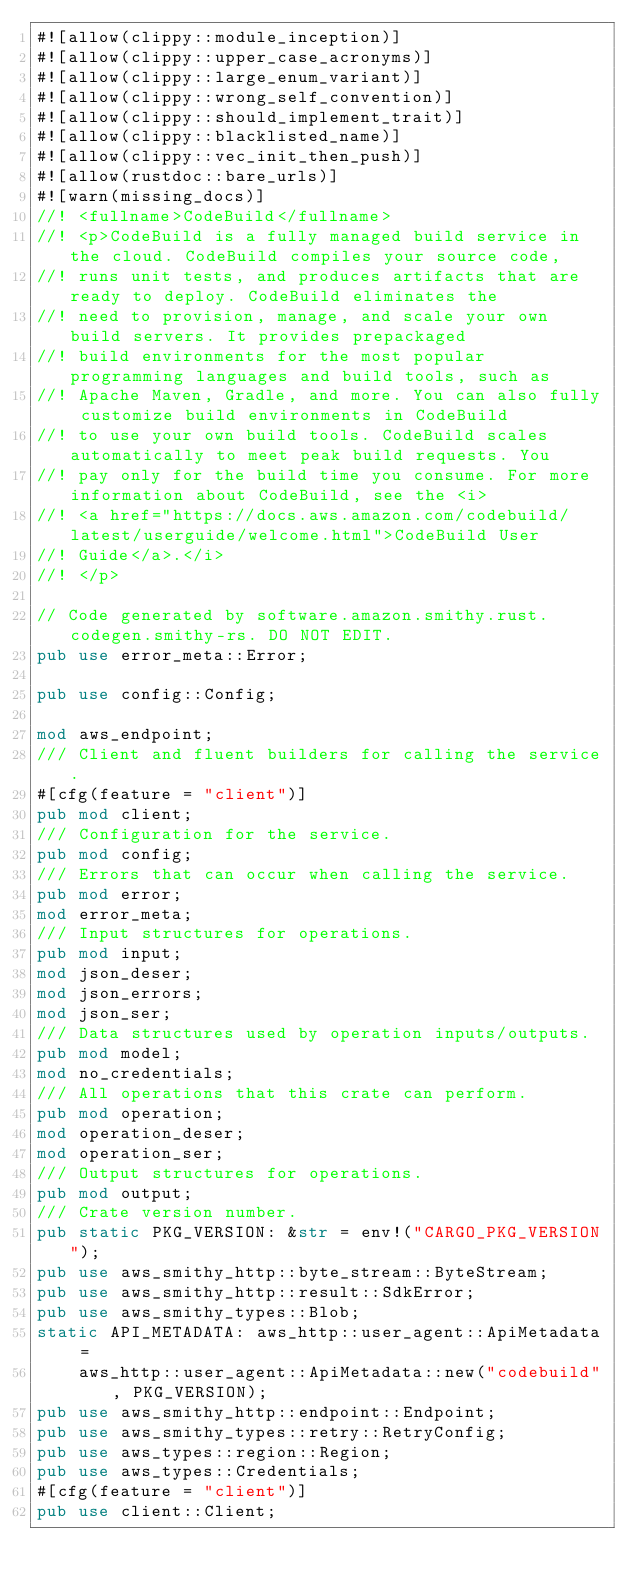Convert code to text. <code><loc_0><loc_0><loc_500><loc_500><_Rust_>#![allow(clippy::module_inception)]
#![allow(clippy::upper_case_acronyms)]
#![allow(clippy::large_enum_variant)]
#![allow(clippy::wrong_self_convention)]
#![allow(clippy::should_implement_trait)]
#![allow(clippy::blacklisted_name)]
#![allow(clippy::vec_init_then_push)]
#![allow(rustdoc::bare_urls)]
#![warn(missing_docs)]
//! <fullname>CodeBuild</fullname>
//! <p>CodeBuild is a fully managed build service in the cloud. CodeBuild compiles your source code,
//! runs unit tests, and produces artifacts that are ready to deploy. CodeBuild eliminates the
//! need to provision, manage, and scale your own build servers. It provides prepackaged
//! build environments for the most popular programming languages and build tools, such as
//! Apache Maven, Gradle, and more. You can also fully customize build environments in CodeBuild
//! to use your own build tools. CodeBuild scales automatically to meet peak build requests. You
//! pay only for the build time you consume. For more information about CodeBuild, see the <i>
//! <a href="https://docs.aws.amazon.com/codebuild/latest/userguide/welcome.html">CodeBuild User
//! Guide</a>.</i>
//! </p>

// Code generated by software.amazon.smithy.rust.codegen.smithy-rs. DO NOT EDIT.
pub use error_meta::Error;

pub use config::Config;

mod aws_endpoint;
/// Client and fluent builders for calling the service.
#[cfg(feature = "client")]
pub mod client;
/// Configuration for the service.
pub mod config;
/// Errors that can occur when calling the service.
pub mod error;
mod error_meta;
/// Input structures for operations.
pub mod input;
mod json_deser;
mod json_errors;
mod json_ser;
/// Data structures used by operation inputs/outputs.
pub mod model;
mod no_credentials;
/// All operations that this crate can perform.
pub mod operation;
mod operation_deser;
mod operation_ser;
/// Output structures for operations.
pub mod output;
/// Crate version number.
pub static PKG_VERSION: &str = env!("CARGO_PKG_VERSION");
pub use aws_smithy_http::byte_stream::ByteStream;
pub use aws_smithy_http::result::SdkError;
pub use aws_smithy_types::Blob;
static API_METADATA: aws_http::user_agent::ApiMetadata =
    aws_http::user_agent::ApiMetadata::new("codebuild", PKG_VERSION);
pub use aws_smithy_http::endpoint::Endpoint;
pub use aws_smithy_types::retry::RetryConfig;
pub use aws_types::region::Region;
pub use aws_types::Credentials;
#[cfg(feature = "client")]
pub use client::Client;
</code> 